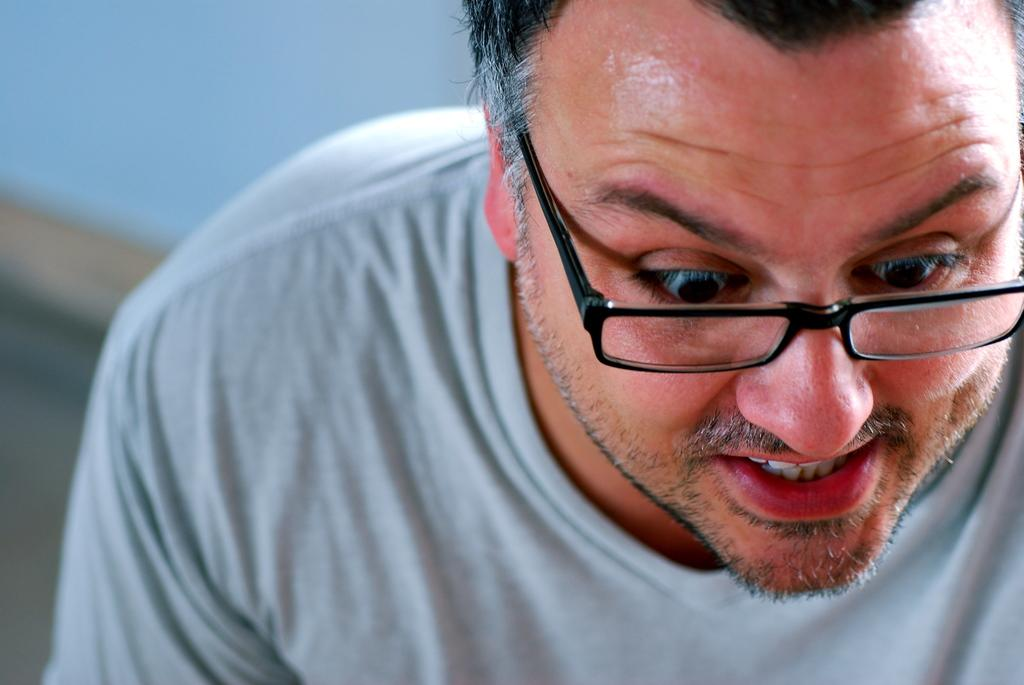What is the main subject of the image? There is a man in the image. What is the man wearing on his upper body? The man is wearing a grey t-shirt. Are there any accessories visible on the man in the image? Yes, the man is wearing specs. What type of amusement can be seen in the image? There is no amusement present in the image; it features a man wearing a grey t-shirt and specs. How many boots is the man wearing in the image? The man is not wearing any boots in the image; he is wearing a grey t-shirt and specs. 